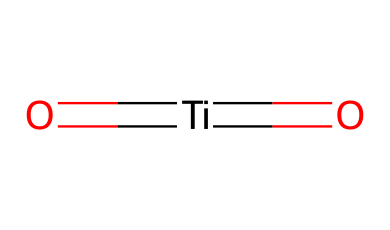What is the central atom in this molecule? The central atom is Titanium, which is represented at the center of the SMILES notation. The brackets and equal signs indicate that Titanium is bonded with oxygen atoms, making it the central element in this chemical structure.
Answer: Titanium How many oxygen atoms are in this compound? The SMILES representation shows two oxygen atoms bonded to the Titanium atom. The presence of two 'O' characters confirms the two oxygen atoms.
Answer: 2 What type of bonding is present in this molecule? The '=' sign in the SMILES notation indicates double bonds between the Titanium and the Oxygen atoms. This notation shows that the bonding involves sharing of multiple electrons between these atoms, characteristic of double bonds.
Answer: double bonding What is the oxidation state of Titanium in this compound? In Titanium dioxide, the typical oxidation state of Titanium is +4. This is derived from the fact that each oxygen has a -2 charge, and to balance the overall charge in the neutral compound, Titanium must be +4.
Answer: +4 What is the primary use of Titanium dioxide in cosmetics? Titanium dioxide is primarily used as a UV filter in sunscreens, where it helps to block harmful UV radiation when applied to the skin. Its properties as a physical sunscreen are well-established in cosmetic formulations.
Answer: UV filter How does the molecular structure of Titanium dioxide relate to its effectiveness in sunscreens? The linear and symmetrical arrangement of Titanium and oxygen allows for effective light scattering properties. This means that when sunlight hits the skin, Titanium dioxide can scatter UV rays across a wide angle, enhancing its protective effectiveness against sunburn.
Answer: light scattering properties Is this compound polar or nonpolar? The presence of Titanium and oxygen, along with their electronegativity difference, suggests that the molecule is polar due to the uneven distribution of electron density. This results in a dipole, making it polar.
Answer: polar 